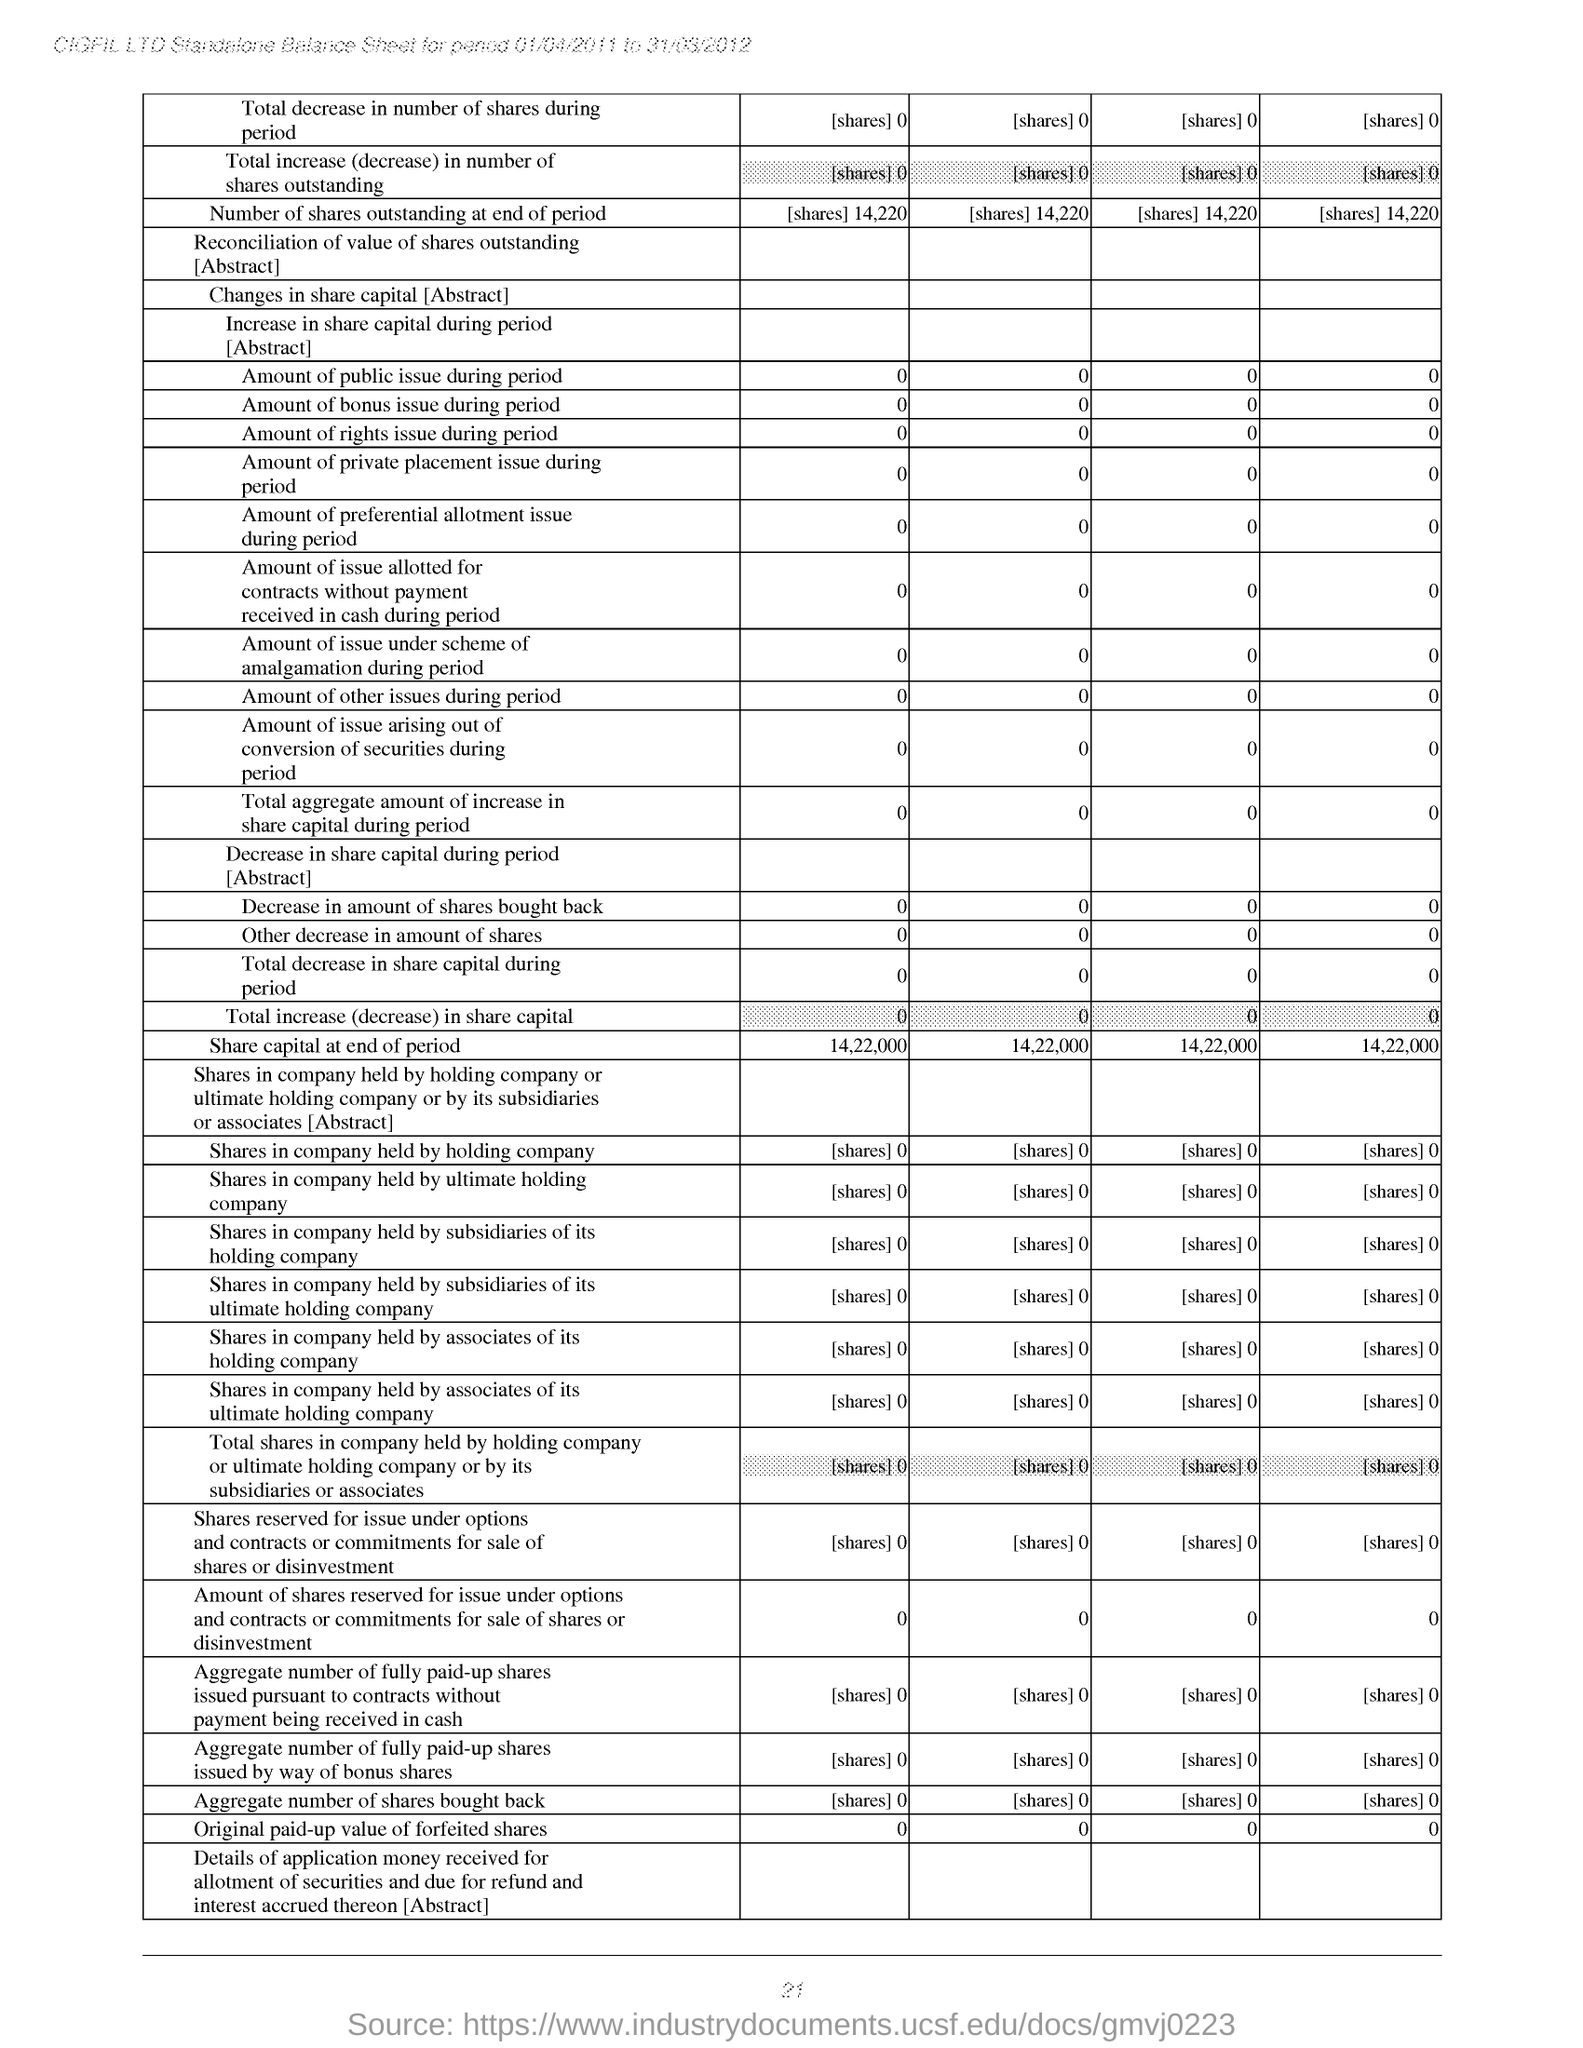Point out several critical features in this image. At the end of the period, the share capital was 14,22,000. 